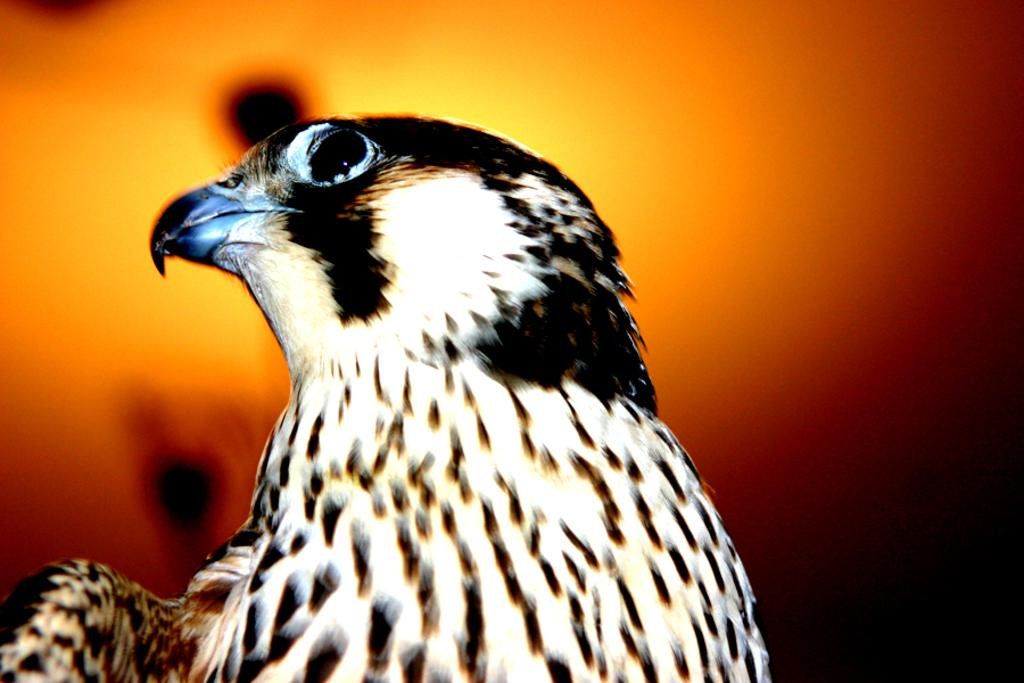What type of animal is in the image? There is a bird in the image. How is the bird depicted in the image? The bird is truncated. What color is the background of the image? The background of the image is orange. Are there any cobwebs visible in the image? There is no mention of cobwebs in the provided facts, and therefore we cannot determine if any are present in the image. 